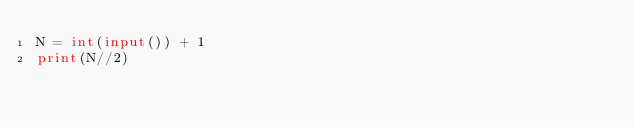<code> <loc_0><loc_0><loc_500><loc_500><_Python_>N = int(input()) + 1
print(N//2)</code> 